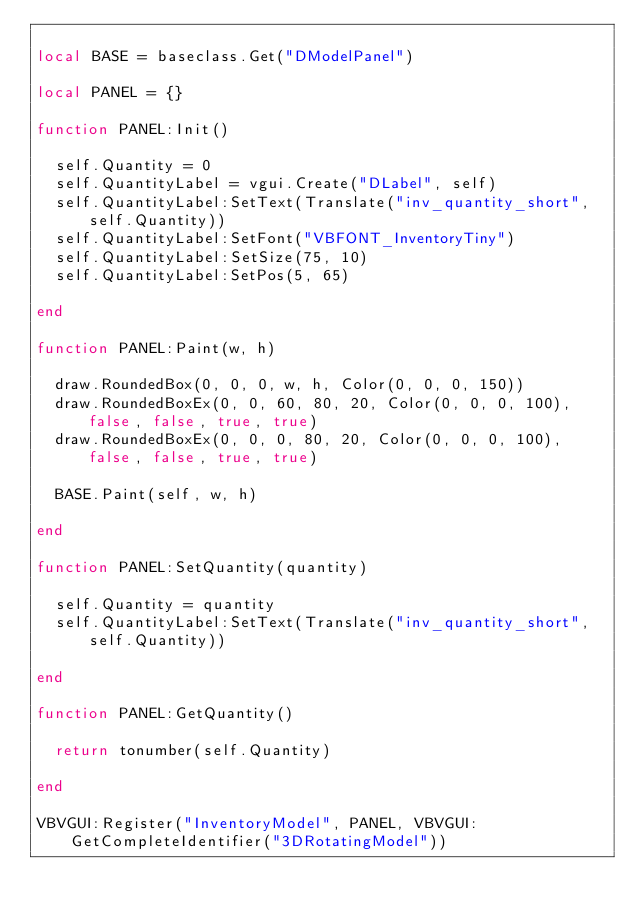Convert code to text. <code><loc_0><loc_0><loc_500><loc_500><_Lua_>
local BASE = baseclass.Get("DModelPanel")

local PANEL = {}

function PANEL:Init()

  self.Quantity = 0
  self.QuantityLabel = vgui.Create("DLabel", self)
  self.QuantityLabel:SetText(Translate("inv_quantity_short", self.Quantity))
  self.QuantityLabel:SetFont("VBFONT_InventoryTiny")
  self.QuantityLabel:SetSize(75, 10)
  self.QuantityLabel:SetPos(5, 65)

end

function PANEL:Paint(w, h)

  draw.RoundedBox(0, 0, 0, w, h, Color(0, 0, 0, 150))
  draw.RoundedBoxEx(0, 0, 60, 80, 20, Color(0, 0, 0, 100), false, false, true, true)
  draw.RoundedBoxEx(0, 0, 0, 80, 20, Color(0, 0, 0, 100), false, false, true, true)

  BASE.Paint(self, w, h)

end

function PANEL:SetQuantity(quantity)

  self.Quantity = quantity
  self.QuantityLabel:SetText(Translate("inv_quantity_short", self.Quantity))

end

function PANEL:GetQuantity()

  return tonumber(self.Quantity)

end

VBVGUI:Register("InventoryModel", PANEL, VBVGUI:GetCompleteIdentifier("3DRotatingModel"))</code> 